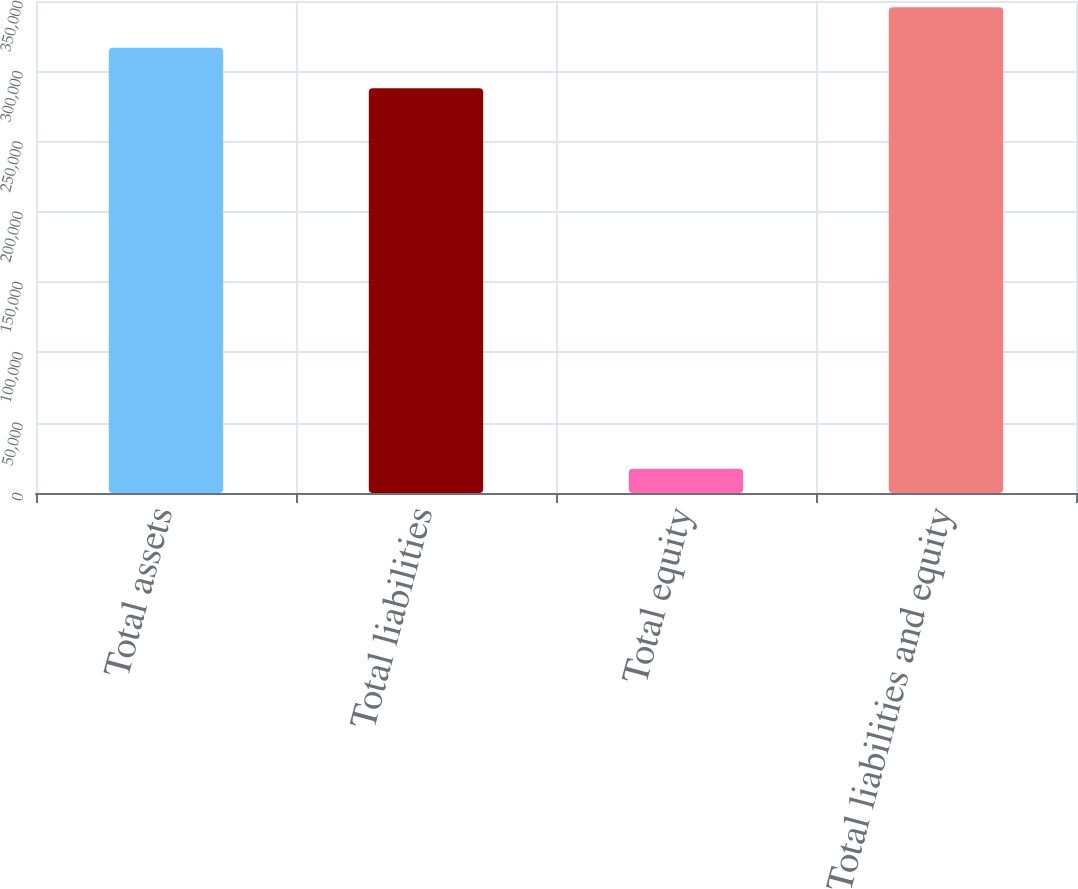<chart> <loc_0><loc_0><loc_500><loc_500><bar_chart><fcel>Total assets<fcel>Total liabilities<fcel>Total equity<fcel>Total liabilities and equity<nl><fcel>316754<fcel>287958<fcel>17283<fcel>345550<nl></chart> 